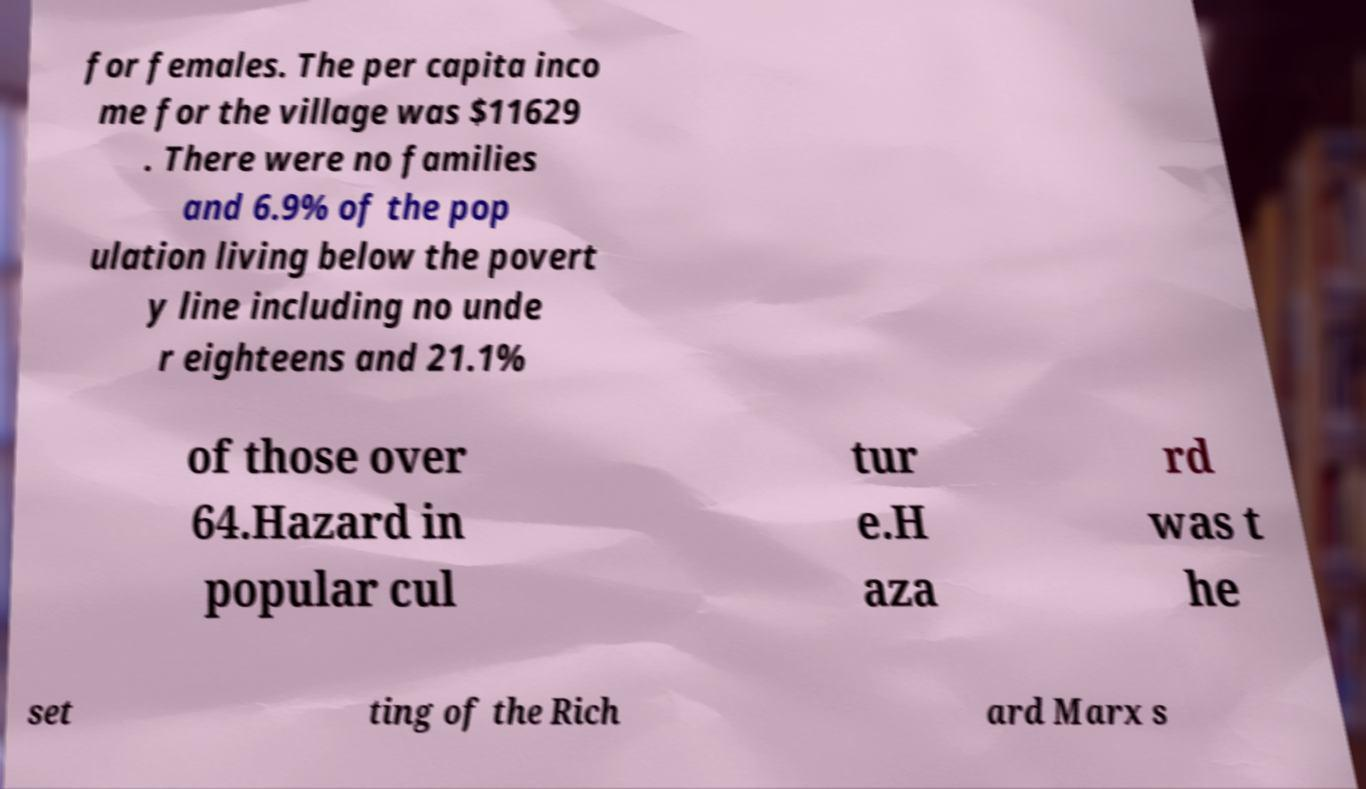Please read and relay the text visible in this image. What does it say? for females. The per capita inco me for the village was $11629 . There were no families and 6.9% of the pop ulation living below the povert y line including no unde r eighteens and 21.1% of those over 64.Hazard in popular cul tur e.H aza rd was t he set ting of the Rich ard Marx s 